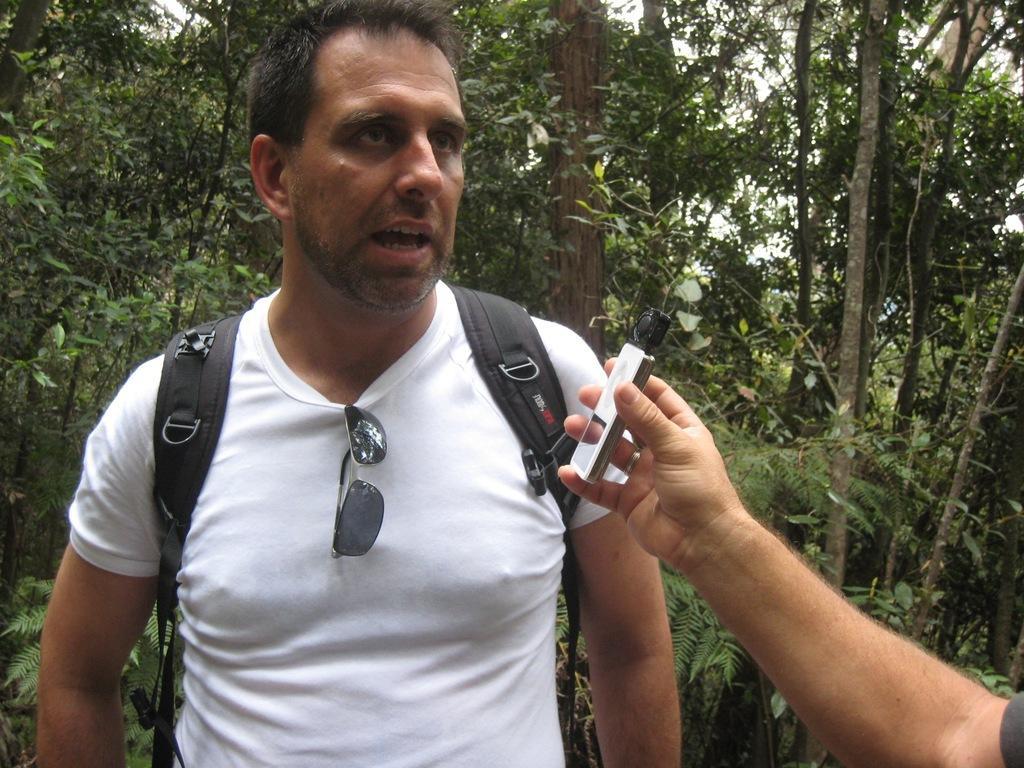How would you summarize this image in a sentence or two? In this image we can see a man. He is wearing a white color T-shirt and carrying black color bag. In the background, we can see trees and the sky. In the right bottom of the image we can see a human hand is holding some device. 